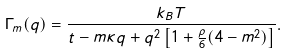Convert formula to latex. <formula><loc_0><loc_0><loc_500><loc_500>\Gamma _ { m } ( q ) = \frac { k _ { B } T } { t - m \kappa q + q ^ { 2 } \left [ 1 + \frac { \rho } { 6 } ( 4 - m ^ { 2 } ) \right ] } .</formula> 